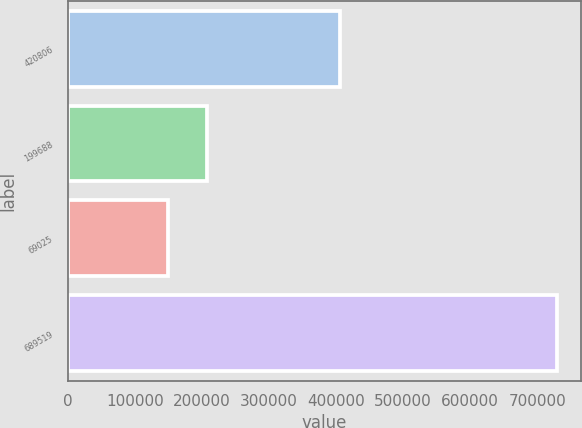Convert chart to OTSL. <chart><loc_0><loc_0><loc_500><loc_500><bar_chart><fcel>420806<fcel>199688<fcel>69025<fcel>689519<nl><fcel>405361<fcel>207561<fcel>149631<fcel>728928<nl></chart> 